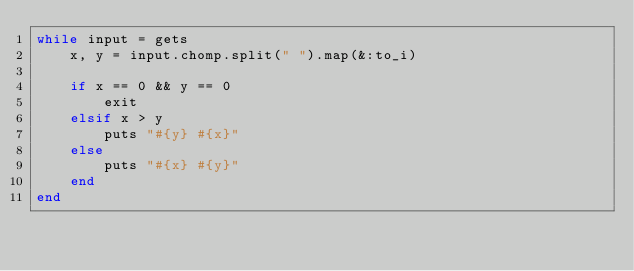Convert code to text. <code><loc_0><loc_0><loc_500><loc_500><_Ruby_>while input = gets
    x, y = input.chomp.split(" ").map(&:to_i)
    
    if x == 0 && y == 0
        exit
    elsif x > y
        puts "#{y} #{x}"
    else
        puts "#{x} #{y}"
    end
end
</code> 